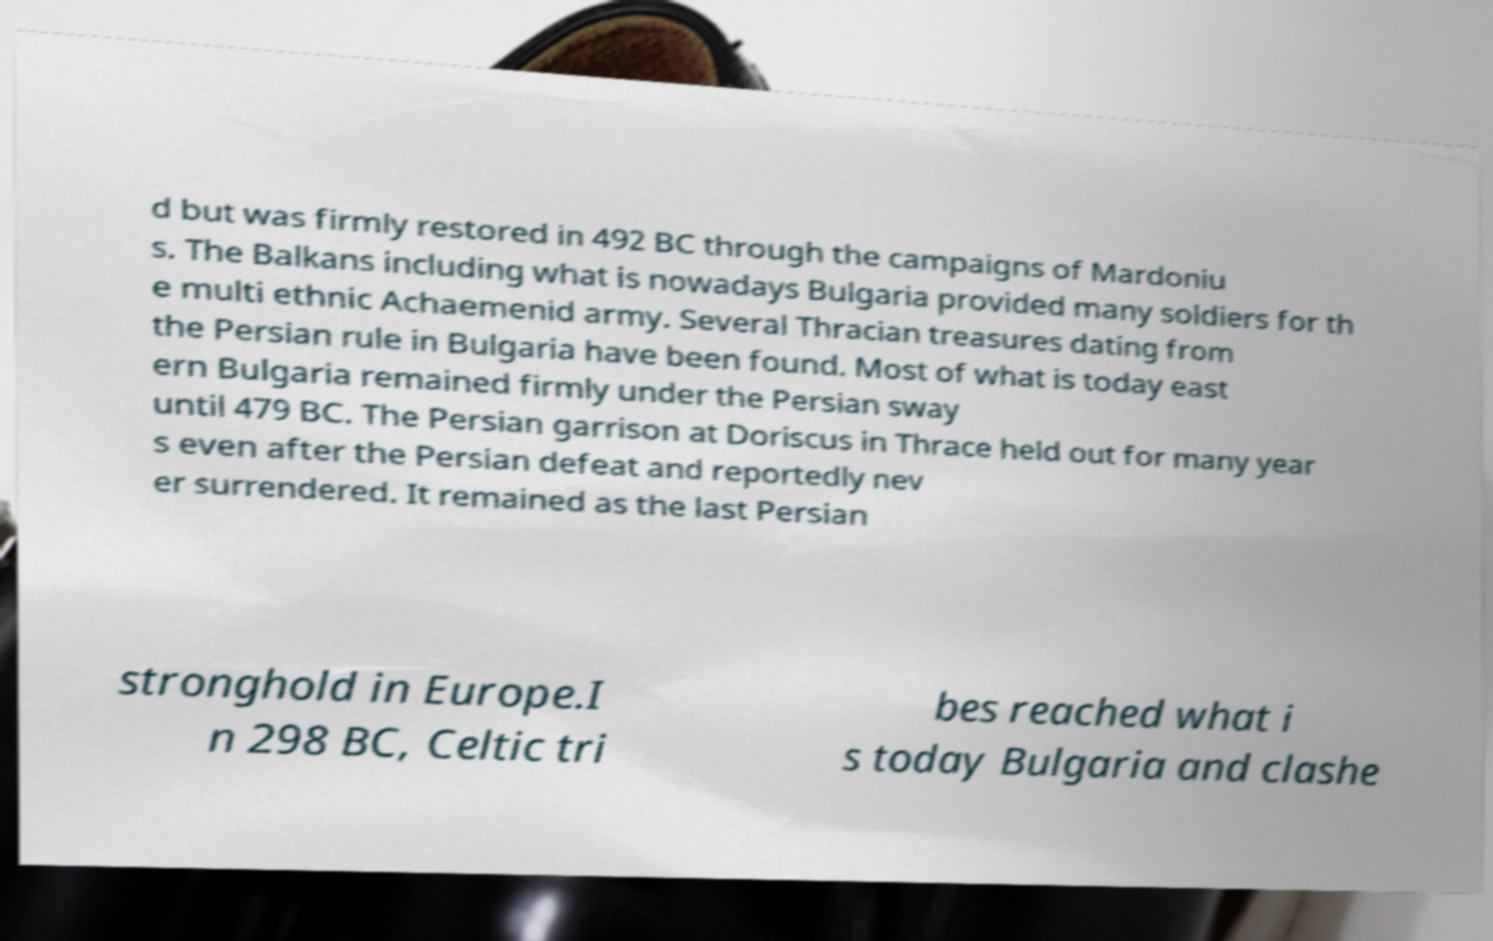Could you extract and type out the text from this image? d but was firmly restored in 492 BC through the campaigns of Mardoniu s. The Balkans including what is nowadays Bulgaria provided many soldiers for th e multi ethnic Achaemenid army. Several Thracian treasures dating from the Persian rule in Bulgaria have been found. Most of what is today east ern Bulgaria remained firmly under the Persian sway until 479 BC. The Persian garrison at Doriscus in Thrace held out for many year s even after the Persian defeat and reportedly nev er surrendered. It remained as the last Persian stronghold in Europe.I n 298 BC, Celtic tri bes reached what i s today Bulgaria and clashe 